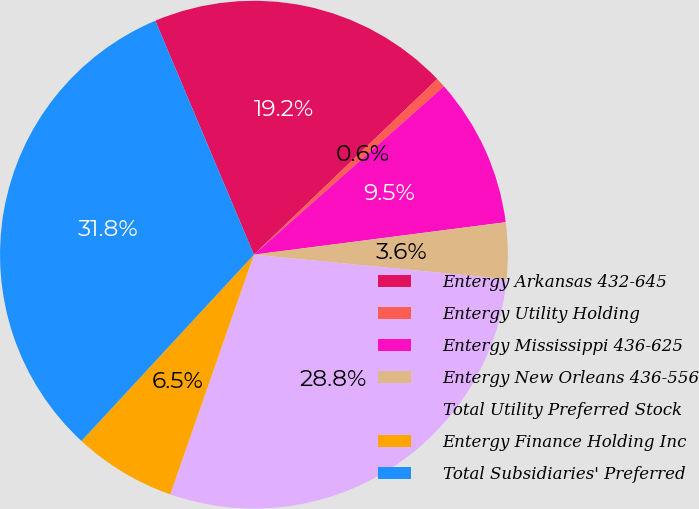<chart> <loc_0><loc_0><loc_500><loc_500><pie_chart><fcel>Entergy Arkansas 432-645<fcel>Entergy Utility Holding<fcel>Entergy Mississippi 436-625<fcel>Entergy New Orleans 436-556<fcel>Total Utility Preferred Stock<fcel>Entergy Finance Holding Inc<fcel>Total Subsidiaries' Preferred<nl><fcel>19.19%<fcel>0.62%<fcel>9.5%<fcel>3.58%<fcel>28.81%<fcel>6.54%<fcel>31.77%<nl></chart> 